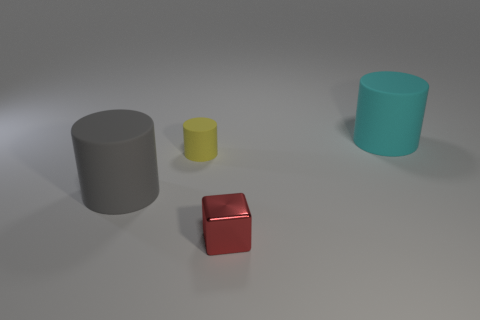Add 3 big matte objects. How many objects exist? 7 Subtract all large cyan matte cylinders. How many cylinders are left? 2 Add 2 matte objects. How many matte objects exist? 5 Subtract all yellow cylinders. How many cylinders are left? 2 Subtract 0 blue cylinders. How many objects are left? 4 Subtract all cylinders. How many objects are left? 1 Subtract all cyan cylinders. Subtract all blue blocks. How many cylinders are left? 2 Subtract all yellow cubes. How many gray cylinders are left? 1 Subtract all blue metallic cylinders. Subtract all tiny red shiny blocks. How many objects are left? 3 Add 2 tiny red cubes. How many tiny red cubes are left? 3 